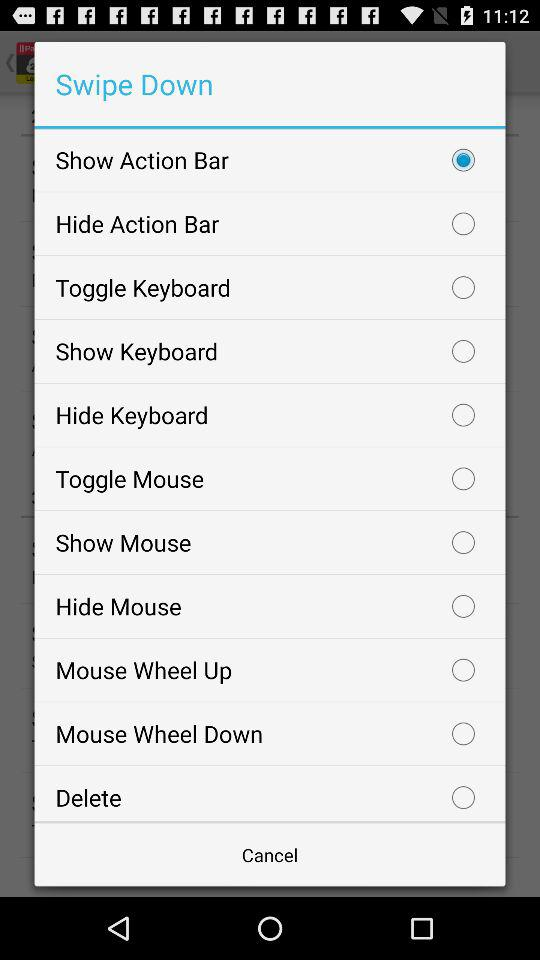What is the selected option? The selected option is "Show Action Bar". 